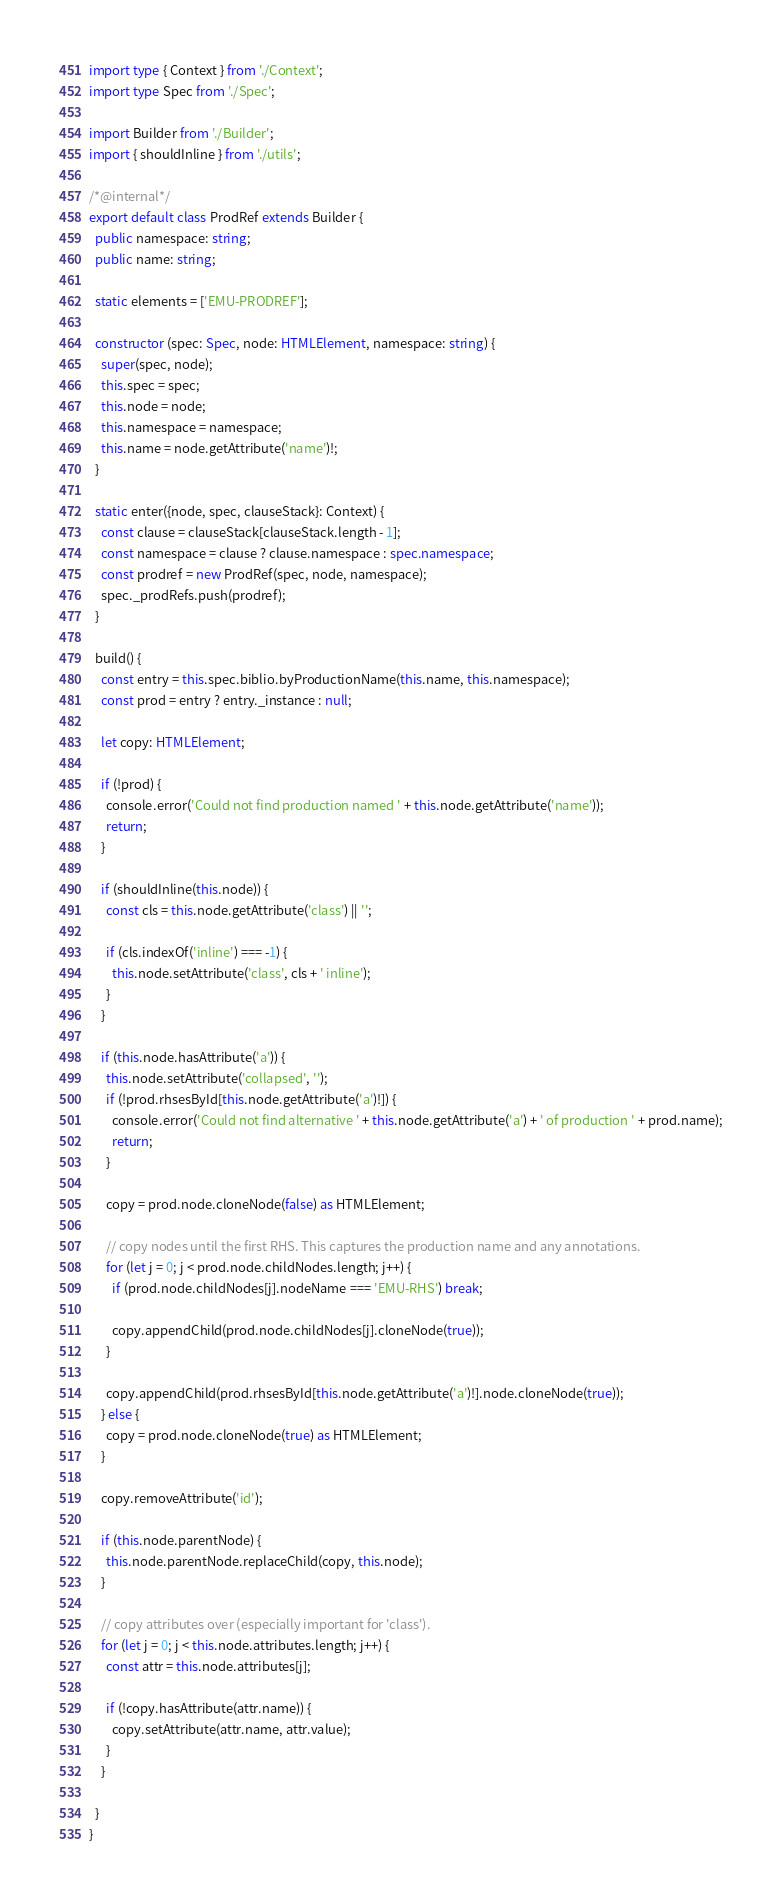<code> <loc_0><loc_0><loc_500><loc_500><_TypeScript_>import type { Context } from './Context';
import type Spec from './Spec';

import Builder from './Builder';
import { shouldInline } from './utils';

/*@internal*/
export default class ProdRef extends Builder {
  public namespace: string;
  public name: string;

  static elements = ['EMU-PRODREF'];

  constructor (spec: Spec, node: HTMLElement, namespace: string) {
    super(spec, node);
    this.spec = spec;
    this.node = node;
    this.namespace = namespace;
    this.name = node.getAttribute('name')!;
  }

  static enter({node, spec, clauseStack}: Context) {
    const clause = clauseStack[clauseStack.length - 1];
    const namespace = clause ? clause.namespace : spec.namespace;
    const prodref = new ProdRef(spec, node, namespace);
    spec._prodRefs.push(prodref);
  }

  build() {
    const entry = this.spec.biblio.byProductionName(this.name, this.namespace);
    const prod = entry ? entry._instance : null;

    let copy: HTMLElement;

    if (!prod) {
      console.error('Could not find production named ' + this.node.getAttribute('name'));
      return;
    }

    if (shouldInline(this.node)) {
      const cls = this.node.getAttribute('class') || '';

      if (cls.indexOf('inline') === -1) {
        this.node.setAttribute('class', cls + ' inline');
      }
    }

    if (this.node.hasAttribute('a')) {
      this.node.setAttribute('collapsed', '');
      if (!prod.rhsesById[this.node.getAttribute('a')!]) {
        console.error('Could not find alternative ' + this.node.getAttribute('a') + ' of production ' + prod.name);
        return;
      }

      copy = prod.node.cloneNode(false) as HTMLElement;

      // copy nodes until the first RHS. This captures the production name and any annotations.
      for (let j = 0; j < prod.node.childNodes.length; j++) {
        if (prod.node.childNodes[j].nodeName === 'EMU-RHS') break;

        copy.appendChild(prod.node.childNodes[j].cloneNode(true));
      }

      copy.appendChild(prod.rhsesById[this.node.getAttribute('a')!].node.cloneNode(true));
    } else {
      copy = prod.node.cloneNode(true) as HTMLElement;
    }

    copy.removeAttribute('id');
    
    if (this.node.parentNode) {
      this.node.parentNode.replaceChild(copy, this.node);
    }

    // copy attributes over (especially important for 'class').
    for (let j = 0; j < this.node.attributes.length; j++) {
      const attr = this.node.attributes[j];

      if (!copy.hasAttribute(attr.name)) {
        copy.setAttribute(attr.name, attr.value);
      }
    }

  }
}
</code> 